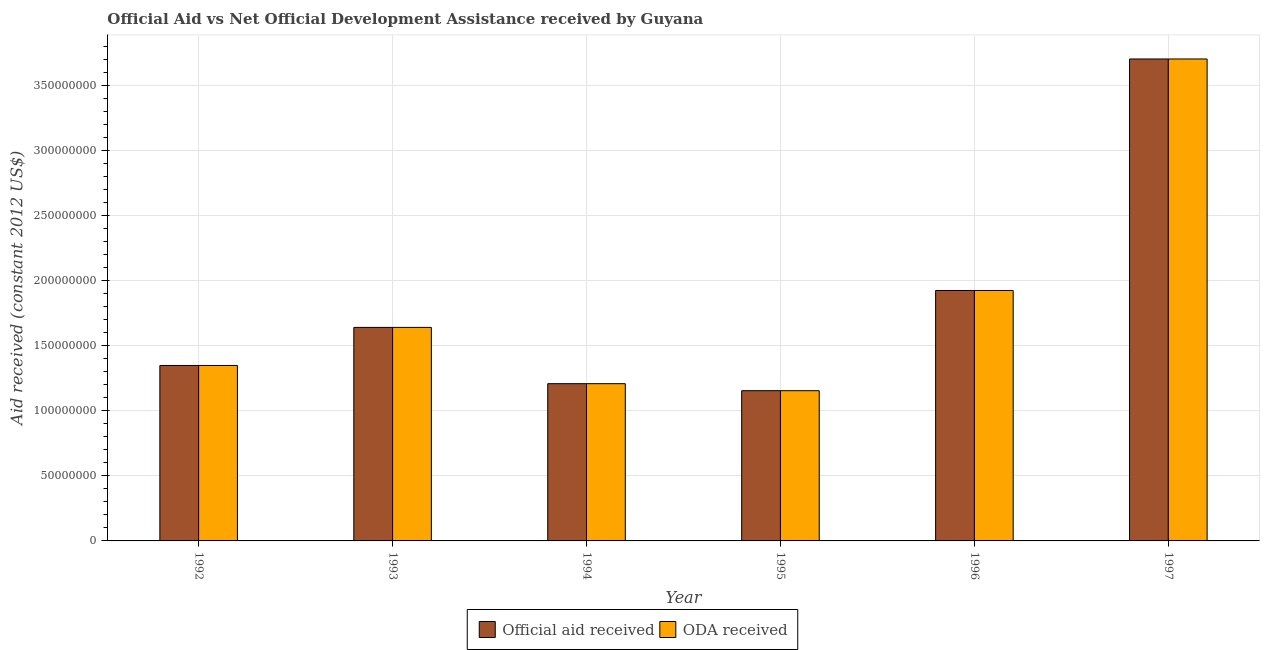How many different coloured bars are there?
Your answer should be very brief. 2. Are the number of bars per tick equal to the number of legend labels?
Your answer should be very brief. Yes. How many bars are there on the 4th tick from the left?
Offer a very short reply. 2. What is the label of the 6th group of bars from the left?
Provide a short and direct response. 1997. In how many cases, is the number of bars for a given year not equal to the number of legend labels?
Make the answer very short. 0. What is the official aid received in 1994?
Ensure brevity in your answer.  1.21e+08. Across all years, what is the maximum official aid received?
Keep it short and to the point. 3.70e+08. Across all years, what is the minimum official aid received?
Your response must be concise. 1.15e+08. In which year was the official aid received maximum?
Provide a short and direct response. 1997. In which year was the official aid received minimum?
Give a very brief answer. 1995. What is the total official aid received in the graph?
Give a very brief answer. 1.10e+09. What is the difference between the oda received in 1995 and that in 1996?
Offer a very short reply. -7.70e+07. What is the difference between the oda received in 1993 and the official aid received in 1995?
Offer a terse response. 4.86e+07. What is the average oda received per year?
Your answer should be compact. 1.83e+08. In the year 1993, what is the difference between the oda received and official aid received?
Offer a very short reply. 0. In how many years, is the official aid received greater than 10000000 US$?
Make the answer very short. 6. What is the ratio of the oda received in 1992 to that in 1995?
Ensure brevity in your answer.  1.17. Is the official aid received in 1992 less than that in 1997?
Keep it short and to the point. Yes. Is the difference between the official aid received in 1996 and 1997 greater than the difference between the oda received in 1996 and 1997?
Your response must be concise. No. What is the difference between the highest and the second highest oda received?
Ensure brevity in your answer.  1.78e+08. What is the difference between the highest and the lowest oda received?
Ensure brevity in your answer.  2.55e+08. What does the 1st bar from the left in 1993 represents?
Make the answer very short. Official aid received. What does the 2nd bar from the right in 1994 represents?
Offer a terse response. Official aid received. How many bars are there?
Provide a succinct answer. 12. What is the difference between two consecutive major ticks on the Y-axis?
Provide a short and direct response. 5.00e+07. Are the values on the major ticks of Y-axis written in scientific E-notation?
Your answer should be compact. No. Does the graph contain any zero values?
Your answer should be very brief. No. Does the graph contain grids?
Offer a very short reply. Yes. How many legend labels are there?
Make the answer very short. 2. What is the title of the graph?
Your response must be concise. Official Aid vs Net Official Development Assistance received by Guyana . Does "Import" appear as one of the legend labels in the graph?
Provide a succinct answer. No. What is the label or title of the X-axis?
Keep it short and to the point. Year. What is the label or title of the Y-axis?
Make the answer very short. Aid received (constant 2012 US$). What is the Aid received (constant 2012 US$) of Official aid received in 1992?
Your answer should be very brief. 1.35e+08. What is the Aid received (constant 2012 US$) in ODA received in 1992?
Your answer should be compact. 1.35e+08. What is the Aid received (constant 2012 US$) of Official aid received in 1993?
Offer a terse response. 1.64e+08. What is the Aid received (constant 2012 US$) of ODA received in 1993?
Provide a succinct answer. 1.64e+08. What is the Aid received (constant 2012 US$) in Official aid received in 1994?
Make the answer very short. 1.21e+08. What is the Aid received (constant 2012 US$) of ODA received in 1994?
Keep it short and to the point. 1.21e+08. What is the Aid received (constant 2012 US$) of Official aid received in 1995?
Offer a terse response. 1.15e+08. What is the Aid received (constant 2012 US$) of ODA received in 1995?
Make the answer very short. 1.15e+08. What is the Aid received (constant 2012 US$) in Official aid received in 1996?
Provide a short and direct response. 1.92e+08. What is the Aid received (constant 2012 US$) of ODA received in 1996?
Your answer should be compact. 1.92e+08. What is the Aid received (constant 2012 US$) in Official aid received in 1997?
Make the answer very short. 3.70e+08. What is the Aid received (constant 2012 US$) in ODA received in 1997?
Your answer should be very brief. 3.70e+08. Across all years, what is the maximum Aid received (constant 2012 US$) of Official aid received?
Keep it short and to the point. 3.70e+08. Across all years, what is the maximum Aid received (constant 2012 US$) in ODA received?
Provide a succinct answer. 3.70e+08. Across all years, what is the minimum Aid received (constant 2012 US$) of Official aid received?
Provide a short and direct response. 1.15e+08. Across all years, what is the minimum Aid received (constant 2012 US$) in ODA received?
Provide a succinct answer. 1.15e+08. What is the total Aid received (constant 2012 US$) in Official aid received in the graph?
Keep it short and to the point. 1.10e+09. What is the total Aid received (constant 2012 US$) in ODA received in the graph?
Your answer should be very brief. 1.10e+09. What is the difference between the Aid received (constant 2012 US$) in Official aid received in 1992 and that in 1993?
Keep it short and to the point. -2.92e+07. What is the difference between the Aid received (constant 2012 US$) in ODA received in 1992 and that in 1993?
Provide a short and direct response. -2.92e+07. What is the difference between the Aid received (constant 2012 US$) in Official aid received in 1992 and that in 1994?
Ensure brevity in your answer.  1.40e+07. What is the difference between the Aid received (constant 2012 US$) of ODA received in 1992 and that in 1994?
Your response must be concise. 1.40e+07. What is the difference between the Aid received (constant 2012 US$) of Official aid received in 1992 and that in 1995?
Your answer should be compact. 1.94e+07. What is the difference between the Aid received (constant 2012 US$) in ODA received in 1992 and that in 1995?
Ensure brevity in your answer.  1.94e+07. What is the difference between the Aid received (constant 2012 US$) in Official aid received in 1992 and that in 1996?
Your answer should be compact. -5.76e+07. What is the difference between the Aid received (constant 2012 US$) in ODA received in 1992 and that in 1996?
Offer a very short reply. -5.76e+07. What is the difference between the Aid received (constant 2012 US$) of Official aid received in 1992 and that in 1997?
Offer a terse response. -2.35e+08. What is the difference between the Aid received (constant 2012 US$) in ODA received in 1992 and that in 1997?
Keep it short and to the point. -2.35e+08. What is the difference between the Aid received (constant 2012 US$) of Official aid received in 1993 and that in 1994?
Ensure brevity in your answer.  4.32e+07. What is the difference between the Aid received (constant 2012 US$) in ODA received in 1993 and that in 1994?
Offer a very short reply. 4.32e+07. What is the difference between the Aid received (constant 2012 US$) in Official aid received in 1993 and that in 1995?
Your answer should be compact. 4.86e+07. What is the difference between the Aid received (constant 2012 US$) in ODA received in 1993 and that in 1995?
Give a very brief answer. 4.86e+07. What is the difference between the Aid received (constant 2012 US$) in Official aid received in 1993 and that in 1996?
Your answer should be compact. -2.84e+07. What is the difference between the Aid received (constant 2012 US$) in ODA received in 1993 and that in 1996?
Give a very brief answer. -2.84e+07. What is the difference between the Aid received (constant 2012 US$) of Official aid received in 1993 and that in 1997?
Your answer should be very brief. -2.06e+08. What is the difference between the Aid received (constant 2012 US$) of ODA received in 1993 and that in 1997?
Make the answer very short. -2.06e+08. What is the difference between the Aid received (constant 2012 US$) of Official aid received in 1994 and that in 1995?
Offer a very short reply. 5.39e+06. What is the difference between the Aid received (constant 2012 US$) of ODA received in 1994 and that in 1995?
Give a very brief answer. 5.39e+06. What is the difference between the Aid received (constant 2012 US$) in Official aid received in 1994 and that in 1996?
Your answer should be very brief. -7.16e+07. What is the difference between the Aid received (constant 2012 US$) in ODA received in 1994 and that in 1996?
Offer a very short reply. -7.16e+07. What is the difference between the Aid received (constant 2012 US$) in Official aid received in 1994 and that in 1997?
Ensure brevity in your answer.  -2.49e+08. What is the difference between the Aid received (constant 2012 US$) of ODA received in 1994 and that in 1997?
Offer a very short reply. -2.49e+08. What is the difference between the Aid received (constant 2012 US$) of Official aid received in 1995 and that in 1996?
Give a very brief answer. -7.70e+07. What is the difference between the Aid received (constant 2012 US$) of ODA received in 1995 and that in 1996?
Keep it short and to the point. -7.70e+07. What is the difference between the Aid received (constant 2012 US$) of Official aid received in 1995 and that in 1997?
Provide a short and direct response. -2.55e+08. What is the difference between the Aid received (constant 2012 US$) of ODA received in 1995 and that in 1997?
Keep it short and to the point. -2.55e+08. What is the difference between the Aid received (constant 2012 US$) of Official aid received in 1996 and that in 1997?
Offer a very short reply. -1.78e+08. What is the difference between the Aid received (constant 2012 US$) of ODA received in 1996 and that in 1997?
Give a very brief answer. -1.78e+08. What is the difference between the Aid received (constant 2012 US$) in Official aid received in 1992 and the Aid received (constant 2012 US$) in ODA received in 1993?
Keep it short and to the point. -2.92e+07. What is the difference between the Aid received (constant 2012 US$) of Official aid received in 1992 and the Aid received (constant 2012 US$) of ODA received in 1994?
Offer a terse response. 1.40e+07. What is the difference between the Aid received (constant 2012 US$) in Official aid received in 1992 and the Aid received (constant 2012 US$) in ODA received in 1995?
Provide a short and direct response. 1.94e+07. What is the difference between the Aid received (constant 2012 US$) of Official aid received in 1992 and the Aid received (constant 2012 US$) of ODA received in 1996?
Offer a very short reply. -5.76e+07. What is the difference between the Aid received (constant 2012 US$) in Official aid received in 1992 and the Aid received (constant 2012 US$) in ODA received in 1997?
Your answer should be compact. -2.35e+08. What is the difference between the Aid received (constant 2012 US$) in Official aid received in 1993 and the Aid received (constant 2012 US$) in ODA received in 1994?
Offer a very short reply. 4.32e+07. What is the difference between the Aid received (constant 2012 US$) in Official aid received in 1993 and the Aid received (constant 2012 US$) in ODA received in 1995?
Offer a very short reply. 4.86e+07. What is the difference between the Aid received (constant 2012 US$) of Official aid received in 1993 and the Aid received (constant 2012 US$) of ODA received in 1996?
Your answer should be compact. -2.84e+07. What is the difference between the Aid received (constant 2012 US$) in Official aid received in 1993 and the Aid received (constant 2012 US$) in ODA received in 1997?
Your answer should be compact. -2.06e+08. What is the difference between the Aid received (constant 2012 US$) of Official aid received in 1994 and the Aid received (constant 2012 US$) of ODA received in 1995?
Make the answer very short. 5.39e+06. What is the difference between the Aid received (constant 2012 US$) in Official aid received in 1994 and the Aid received (constant 2012 US$) in ODA received in 1996?
Offer a terse response. -7.16e+07. What is the difference between the Aid received (constant 2012 US$) in Official aid received in 1994 and the Aid received (constant 2012 US$) in ODA received in 1997?
Provide a short and direct response. -2.49e+08. What is the difference between the Aid received (constant 2012 US$) in Official aid received in 1995 and the Aid received (constant 2012 US$) in ODA received in 1996?
Your response must be concise. -7.70e+07. What is the difference between the Aid received (constant 2012 US$) in Official aid received in 1995 and the Aid received (constant 2012 US$) in ODA received in 1997?
Offer a very short reply. -2.55e+08. What is the difference between the Aid received (constant 2012 US$) in Official aid received in 1996 and the Aid received (constant 2012 US$) in ODA received in 1997?
Your response must be concise. -1.78e+08. What is the average Aid received (constant 2012 US$) in Official aid received per year?
Provide a succinct answer. 1.83e+08. What is the average Aid received (constant 2012 US$) in ODA received per year?
Your answer should be very brief. 1.83e+08. In the year 1992, what is the difference between the Aid received (constant 2012 US$) in Official aid received and Aid received (constant 2012 US$) in ODA received?
Your answer should be compact. 0. What is the ratio of the Aid received (constant 2012 US$) in Official aid received in 1992 to that in 1993?
Keep it short and to the point. 0.82. What is the ratio of the Aid received (constant 2012 US$) of ODA received in 1992 to that in 1993?
Give a very brief answer. 0.82. What is the ratio of the Aid received (constant 2012 US$) in Official aid received in 1992 to that in 1994?
Provide a short and direct response. 1.12. What is the ratio of the Aid received (constant 2012 US$) of ODA received in 1992 to that in 1994?
Offer a terse response. 1.12. What is the ratio of the Aid received (constant 2012 US$) of Official aid received in 1992 to that in 1995?
Provide a succinct answer. 1.17. What is the ratio of the Aid received (constant 2012 US$) in ODA received in 1992 to that in 1995?
Make the answer very short. 1.17. What is the ratio of the Aid received (constant 2012 US$) of Official aid received in 1992 to that in 1996?
Ensure brevity in your answer.  0.7. What is the ratio of the Aid received (constant 2012 US$) of ODA received in 1992 to that in 1996?
Your answer should be compact. 0.7. What is the ratio of the Aid received (constant 2012 US$) in Official aid received in 1992 to that in 1997?
Your answer should be very brief. 0.36. What is the ratio of the Aid received (constant 2012 US$) in ODA received in 1992 to that in 1997?
Make the answer very short. 0.36. What is the ratio of the Aid received (constant 2012 US$) of Official aid received in 1993 to that in 1994?
Keep it short and to the point. 1.36. What is the ratio of the Aid received (constant 2012 US$) of ODA received in 1993 to that in 1994?
Your answer should be very brief. 1.36. What is the ratio of the Aid received (constant 2012 US$) in Official aid received in 1993 to that in 1995?
Your response must be concise. 1.42. What is the ratio of the Aid received (constant 2012 US$) in ODA received in 1993 to that in 1995?
Make the answer very short. 1.42. What is the ratio of the Aid received (constant 2012 US$) of Official aid received in 1993 to that in 1996?
Offer a terse response. 0.85. What is the ratio of the Aid received (constant 2012 US$) in ODA received in 1993 to that in 1996?
Make the answer very short. 0.85. What is the ratio of the Aid received (constant 2012 US$) of Official aid received in 1993 to that in 1997?
Your answer should be compact. 0.44. What is the ratio of the Aid received (constant 2012 US$) of ODA received in 1993 to that in 1997?
Provide a succinct answer. 0.44. What is the ratio of the Aid received (constant 2012 US$) in Official aid received in 1994 to that in 1995?
Keep it short and to the point. 1.05. What is the ratio of the Aid received (constant 2012 US$) in ODA received in 1994 to that in 1995?
Give a very brief answer. 1.05. What is the ratio of the Aid received (constant 2012 US$) in Official aid received in 1994 to that in 1996?
Your answer should be very brief. 0.63. What is the ratio of the Aid received (constant 2012 US$) in ODA received in 1994 to that in 1996?
Give a very brief answer. 0.63. What is the ratio of the Aid received (constant 2012 US$) of Official aid received in 1994 to that in 1997?
Offer a very short reply. 0.33. What is the ratio of the Aid received (constant 2012 US$) of ODA received in 1994 to that in 1997?
Make the answer very short. 0.33. What is the ratio of the Aid received (constant 2012 US$) of Official aid received in 1995 to that in 1996?
Give a very brief answer. 0.6. What is the ratio of the Aid received (constant 2012 US$) of ODA received in 1995 to that in 1996?
Offer a terse response. 0.6. What is the ratio of the Aid received (constant 2012 US$) of Official aid received in 1995 to that in 1997?
Your answer should be very brief. 0.31. What is the ratio of the Aid received (constant 2012 US$) in ODA received in 1995 to that in 1997?
Your answer should be compact. 0.31. What is the ratio of the Aid received (constant 2012 US$) of Official aid received in 1996 to that in 1997?
Provide a short and direct response. 0.52. What is the ratio of the Aid received (constant 2012 US$) in ODA received in 1996 to that in 1997?
Provide a short and direct response. 0.52. What is the difference between the highest and the second highest Aid received (constant 2012 US$) of Official aid received?
Offer a very short reply. 1.78e+08. What is the difference between the highest and the second highest Aid received (constant 2012 US$) in ODA received?
Provide a short and direct response. 1.78e+08. What is the difference between the highest and the lowest Aid received (constant 2012 US$) of Official aid received?
Ensure brevity in your answer.  2.55e+08. What is the difference between the highest and the lowest Aid received (constant 2012 US$) in ODA received?
Provide a succinct answer. 2.55e+08. 